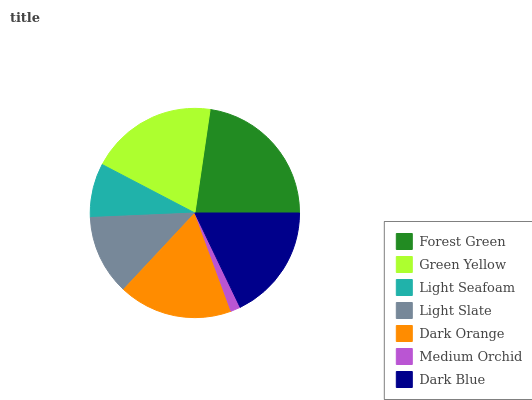Is Medium Orchid the minimum?
Answer yes or no. Yes. Is Forest Green the maximum?
Answer yes or no. Yes. Is Green Yellow the minimum?
Answer yes or no. No. Is Green Yellow the maximum?
Answer yes or no. No. Is Forest Green greater than Green Yellow?
Answer yes or no. Yes. Is Green Yellow less than Forest Green?
Answer yes or no. Yes. Is Green Yellow greater than Forest Green?
Answer yes or no. No. Is Forest Green less than Green Yellow?
Answer yes or no. No. Is Dark Orange the high median?
Answer yes or no. Yes. Is Dark Orange the low median?
Answer yes or no. Yes. Is Light Slate the high median?
Answer yes or no. No. Is Green Yellow the low median?
Answer yes or no. No. 